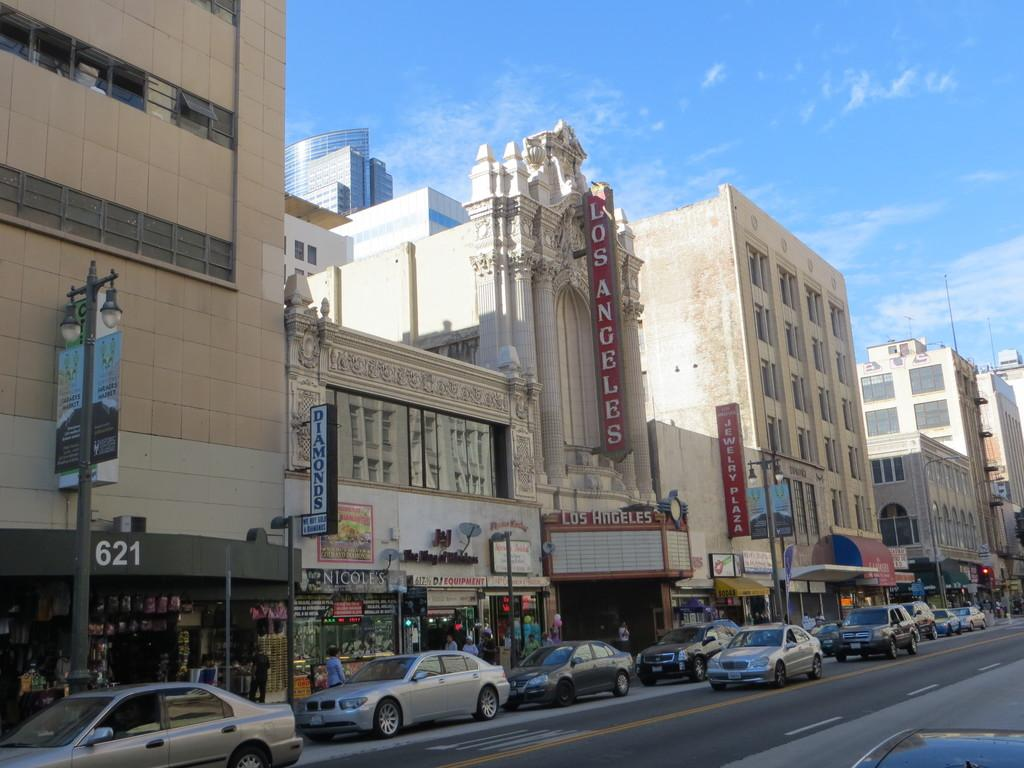What can be seen on the road in the image? There are vehicles on the road in the image. What type of markings are present on the road? The road has yellow and white color lines. What can be seen in the background of the image? There are hoardings and buildings in the background. What is the color of the sky in the image? The sky is blue with clouds in the image. What type of knowledge can be gained from the furniture in the image? There is no furniture present in the image, so no knowledge can be gained from it. 